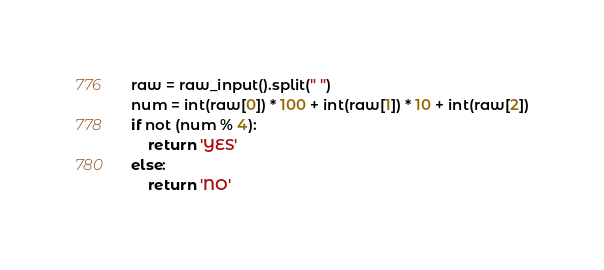Convert code to text. <code><loc_0><loc_0><loc_500><loc_500><_Python_>raw = raw_input().split(" ")
num = int(raw[0]) * 100 + int(raw[1]) * 10 + int(raw[2])
if not (num % 4):
    return 'YES'
else:
    return 'NO'
</code> 